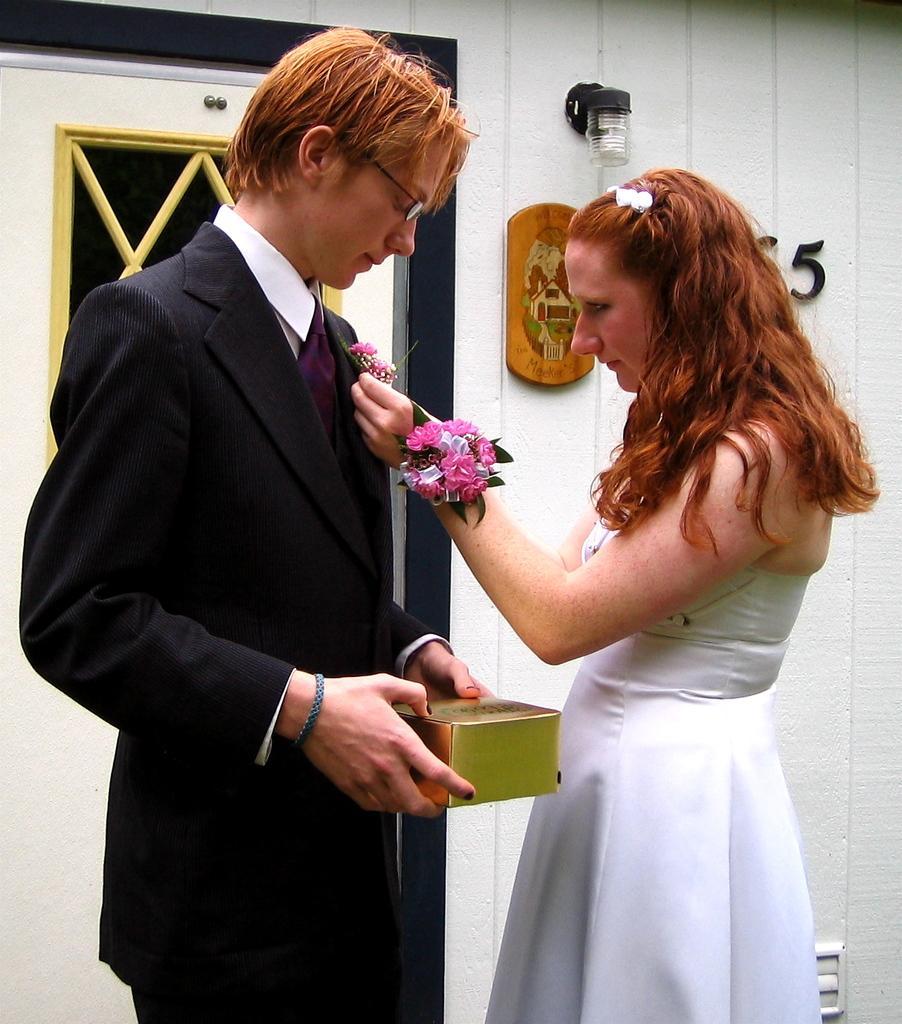Please provide a concise description of this image. In this image there is a woman putting flowers on the person suit. The person is holding the box in his hands. Behind them there is a door. There is a light. There is a board and letters on the wall. 